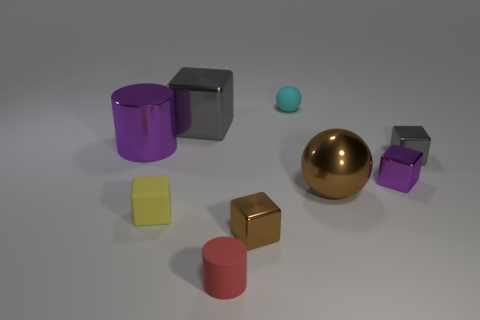Subtract all matte blocks. How many blocks are left? 4 Subtract 1 spheres. How many spheres are left? 1 Subtract all yellow blocks. How many blocks are left? 4 Subtract all blocks. How many objects are left? 4 Subtract all red balls. How many red cubes are left? 0 Subtract 1 purple cylinders. How many objects are left? 8 Subtract all yellow cylinders. Subtract all purple balls. How many cylinders are left? 2 Subtract all yellow rubber cylinders. Subtract all small cyan matte spheres. How many objects are left? 8 Add 6 large purple things. How many large purple things are left? 7 Add 8 tiny blue metallic objects. How many tiny blue metallic objects exist? 8 